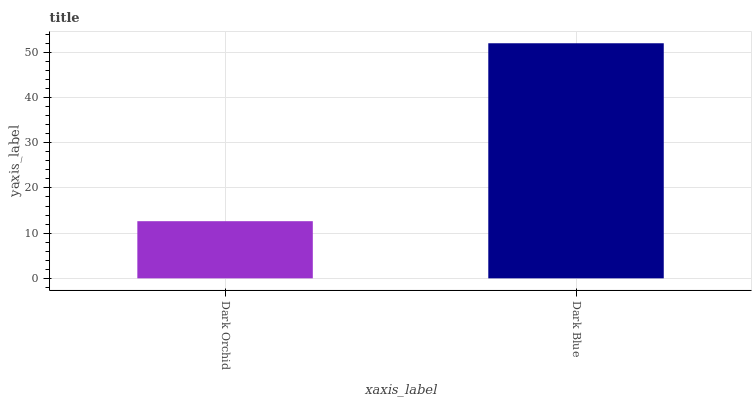Is Dark Orchid the minimum?
Answer yes or no. Yes. Is Dark Blue the maximum?
Answer yes or no. Yes. Is Dark Blue the minimum?
Answer yes or no. No. Is Dark Blue greater than Dark Orchid?
Answer yes or no. Yes. Is Dark Orchid less than Dark Blue?
Answer yes or no. Yes. Is Dark Orchid greater than Dark Blue?
Answer yes or no. No. Is Dark Blue less than Dark Orchid?
Answer yes or no. No. Is Dark Blue the high median?
Answer yes or no. Yes. Is Dark Orchid the low median?
Answer yes or no. Yes. Is Dark Orchid the high median?
Answer yes or no. No. Is Dark Blue the low median?
Answer yes or no. No. 